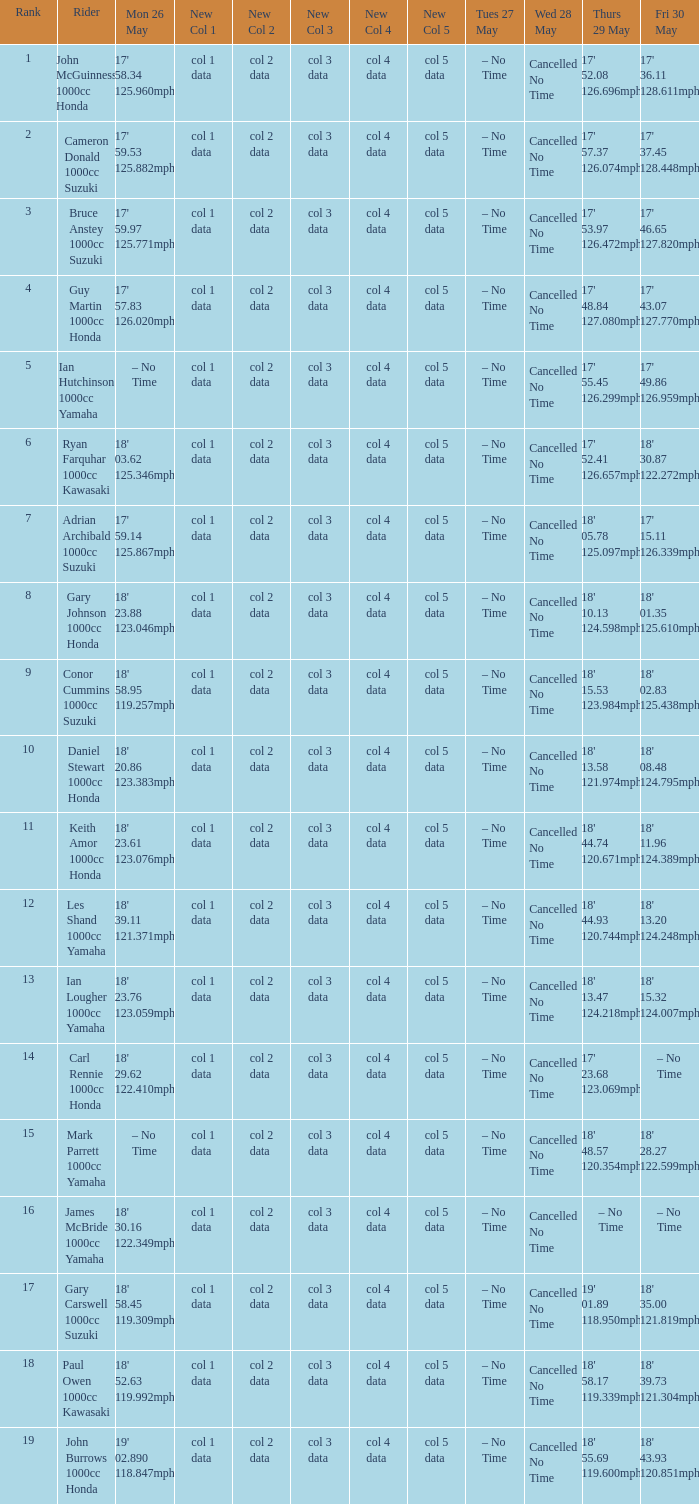What is the numbr for fri may 30 and mon may 26 is 19' 02.890 118.847mph? 18' 43.93 120.851mph. 